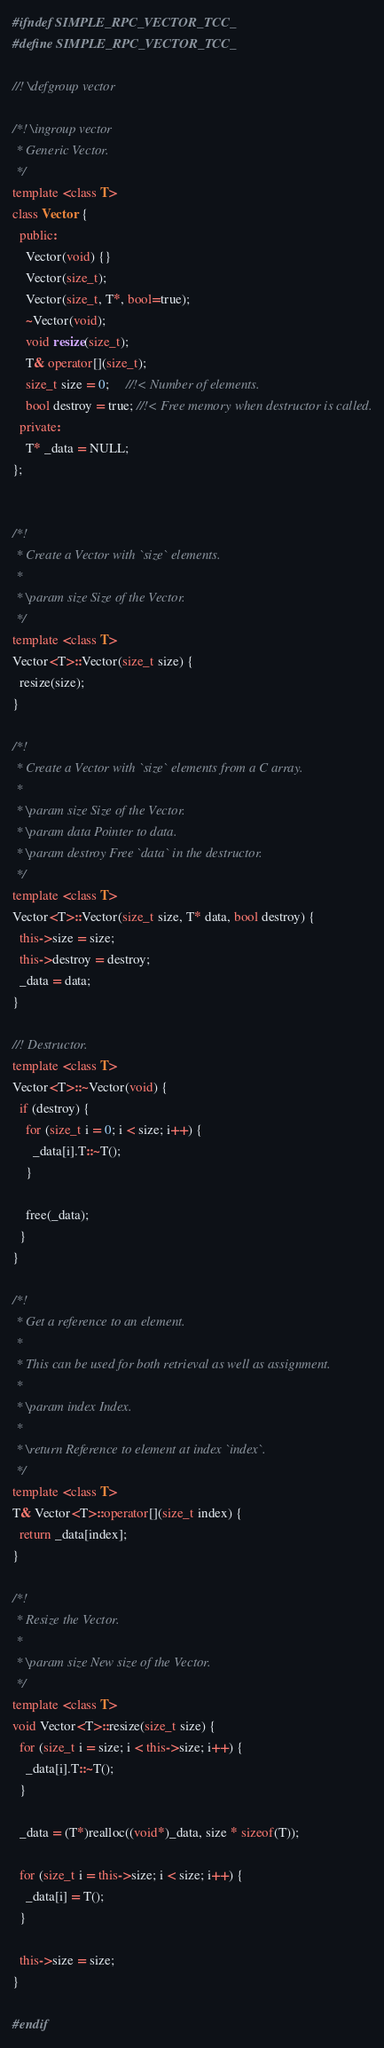<code> <loc_0><loc_0><loc_500><loc_500><_C++_>#ifndef SIMPLE_RPC_VECTOR_TCC_
#define SIMPLE_RPC_VECTOR_TCC_

//! \defgroup vector

/*! \ingroup vector
 * Generic Vector.
 */
template <class T>
class Vector {
  public:
    Vector(void) {}
    Vector(size_t);
    Vector(size_t, T*, bool=true);
    ~Vector(void);
    void resize(size_t);
    T& operator[](size_t);
    size_t size = 0;     //!< Number of elements.
    bool destroy = true; //!< Free memory when destructor is called.
  private:
    T* _data = NULL;
};


/*!
 * Create a Vector with `size` elements.
 *
 * \param size Size of the Vector.
 */
template <class T>
Vector<T>::Vector(size_t size) {
  resize(size);
}

/*!
 * Create a Vector with `size` elements from a C array.
 *
 * \param size Size of the Vector.
 * \param data Pointer to data.
 * \param destroy Free `data` in the destructor.
 */
template <class T>
Vector<T>::Vector(size_t size, T* data, bool destroy) {
  this->size = size;
  this->destroy = destroy;
  _data = data;
}

//! Destructor.
template <class T>
Vector<T>::~Vector(void) {
  if (destroy) {
    for (size_t i = 0; i < size; i++) {
      _data[i].T::~T();
    }

    free(_data);
  }
}

/*!
 * Get a reference to an element.
 *
 * This can be used for both retrieval as well as assignment.
 *
 * \param index Index.
 *
 * \return Reference to element at index `index`.
 */
template <class T>
T& Vector<T>::operator[](size_t index) {
  return _data[index];
}

/*!
 * Resize the Vector.
 *
 * \param size New size of the Vector.
 */
template <class T>
void Vector<T>::resize(size_t size) {
  for (size_t i = size; i < this->size; i++) {
    _data[i].T::~T();
  }

  _data = (T*)realloc((void*)_data, size * sizeof(T));

  for (size_t i = this->size; i < size; i++) {
    _data[i] = T();
  }

  this->size = size;
}

#endif
</code> 